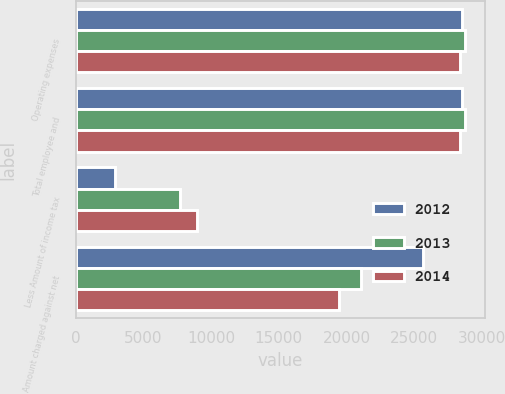Convert chart. <chart><loc_0><loc_0><loc_500><loc_500><stacked_bar_chart><ecel><fcel>Operating expenses<fcel>Total employee and<fcel>Less Amount of income tax<fcel>Amount charged against net<nl><fcel>2012<fcel>28552<fcel>28552<fcel>2932<fcel>25620<nl><fcel>2013<fcel>28764<fcel>28764<fcel>7730<fcel>21034<nl><fcel>2014<fcel>28413<fcel>28413<fcel>8933<fcel>19480<nl></chart> 